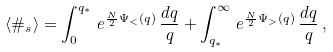<formula> <loc_0><loc_0><loc_500><loc_500>\langle \# _ { s } \rangle = \int _ { 0 } ^ { q _ { * } } \, e ^ { \frac { N } { 2 } \Psi _ { < } ( q ) } \, \frac { d q } { q } + \int _ { q _ { * } } ^ { \infty } \, e ^ { \frac { N } { 2 } \Psi _ { > } ( q ) } \, \frac { d q } { q } \, ,</formula> 